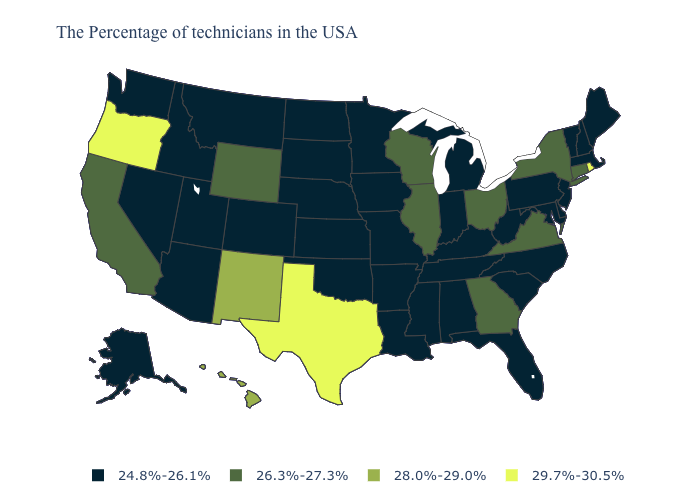What is the highest value in the USA?
Keep it brief. 29.7%-30.5%. Name the states that have a value in the range 24.8%-26.1%?
Keep it brief. Maine, Massachusetts, New Hampshire, Vermont, New Jersey, Delaware, Maryland, Pennsylvania, North Carolina, South Carolina, West Virginia, Florida, Michigan, Kentucky, Indiana, Alabama, Tennessee, Mississippi, Louisiana, Missouri, Arkansas, Minnesota, Iowa, Kansas, Nebraska, Oklahoma, South Dakota, North Dakota, Colorado, Utah, Montana, Arizona, Idaho, Nevada, Washington, Alaska. Does the first symbol in the legend represent the smallest category?
Keep it brief. Yes. Name the states that have a value in the range 29.7%-30.5%?
Quick response, please. Rhode Island, Texas, Oregon. Name the states that have a value in the range 28.0%-29.0%?
Concise answer only. New Mexico, Hawaii. Does Georgia have the lowest value in the South?
Write a very short answer. No. Name the states that have a value in the range 28.0%-29.0%?
Quick response, please. New Mexico, Hawaii. Does Illinois have a lower value than Texas?
Keep it brief. Yes. What is the lowest value in states that border Ohio?
Answer briefly. 24.8%-26.1%. Does Connecticut have the lowest value in the Northeast?
Write a very short answer. No. What is the value of Wisconsin?
Concise answer only. 26.3%-27.3%. Among the states that border Nebraska , does Wyoming have the lowest value?
Give a very brief answer. No. Does Alaska have a lower value than Arkansas?
Give a very brief answer. No. Which states have the highest value in the USA?
Short answer required. Rhode Island, Texas, Oregon. Name the states that have a value in the range 28.0%-29.0%?
Keep it brief. New Mexico, Hawaii. 